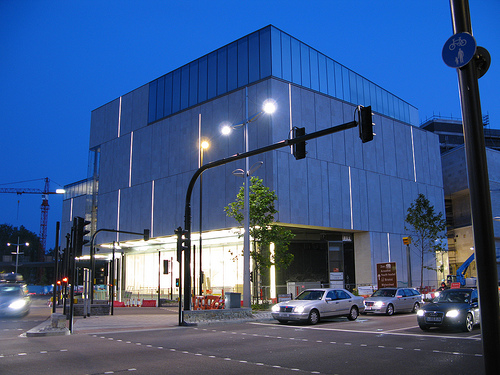Can you describe the weather conditions in this image? The weather conditions appear to be clear with no visible precipitation, and the visibility is good, which can be inferred from the clear sky and the sharpness of the building's lights. 